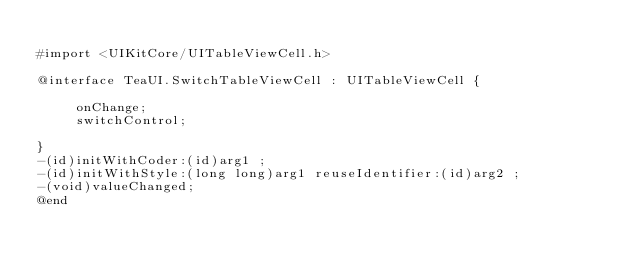Convert code to text. <code><loc_0><loc_0><loc_500><loc_500><_C_>
#import <UIKitCore/UITableViewCell.h>

@interface TeaUI.SwitchTableViewCell : UITableViewCell {

	 onChange;
	 switchControl;

}
-(id)initWithCoder:(id)arg1 ;
-(id)initWithStyle:(long long)arg1 reuseIdentifier:(id)arg2 ;
-(void)valueChanged;
@end

</code> 